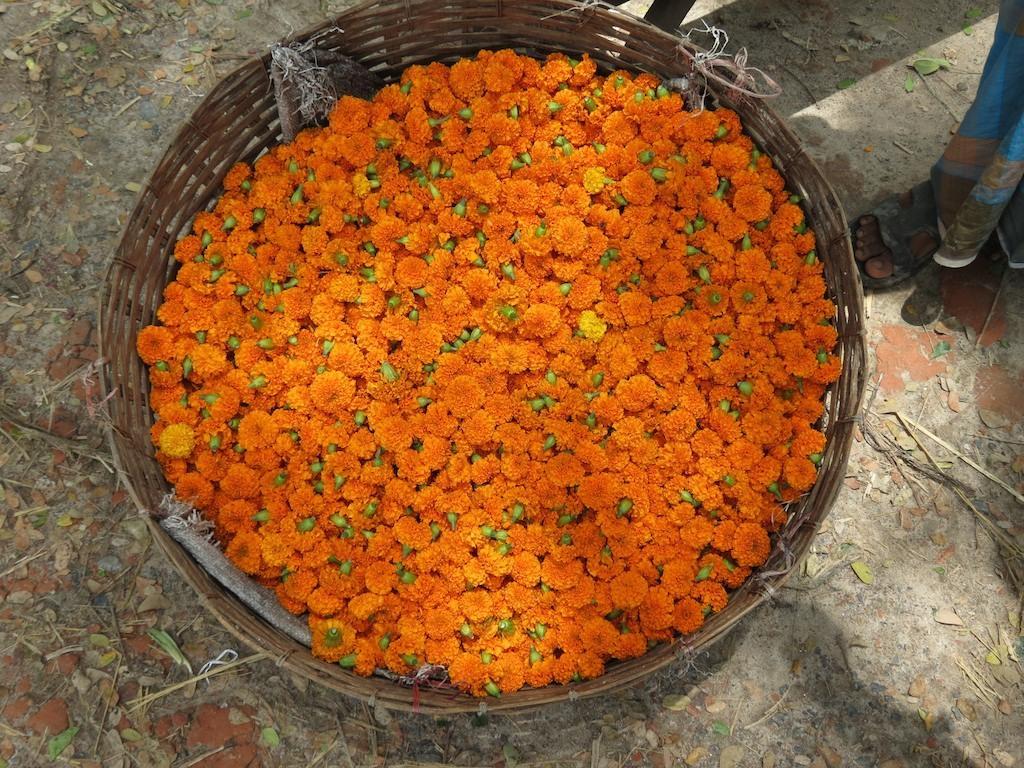Could you give a brief overview of what you see in this image? In the image we can see a basket, in the basket there are flowers, orange in color. These are the dry leaves, this is a human leg and this is a sandal. 